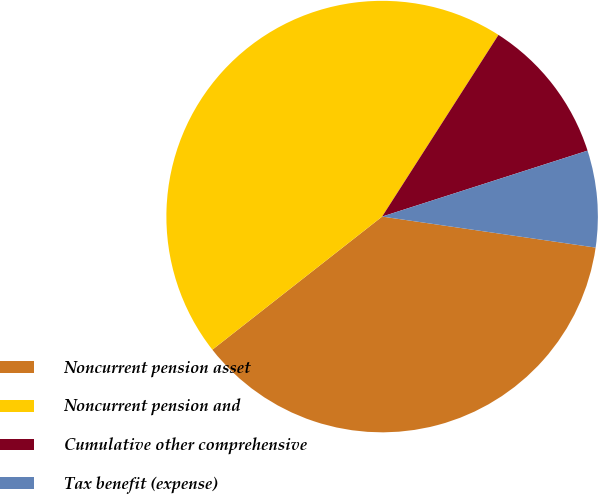<chart> <loc_0><loc_0><loc_500><loc_500><pie_chart><fcel>Noncurrent pension asset<fcel>Noncurrent pension and<fcel>Cumulative other comprehensive<fcel>Tax benefit (expense)<nl><fcel>37.12%<fcel>44.65%<fcel>10.99%<fcel>7.24%<nl></chart> 